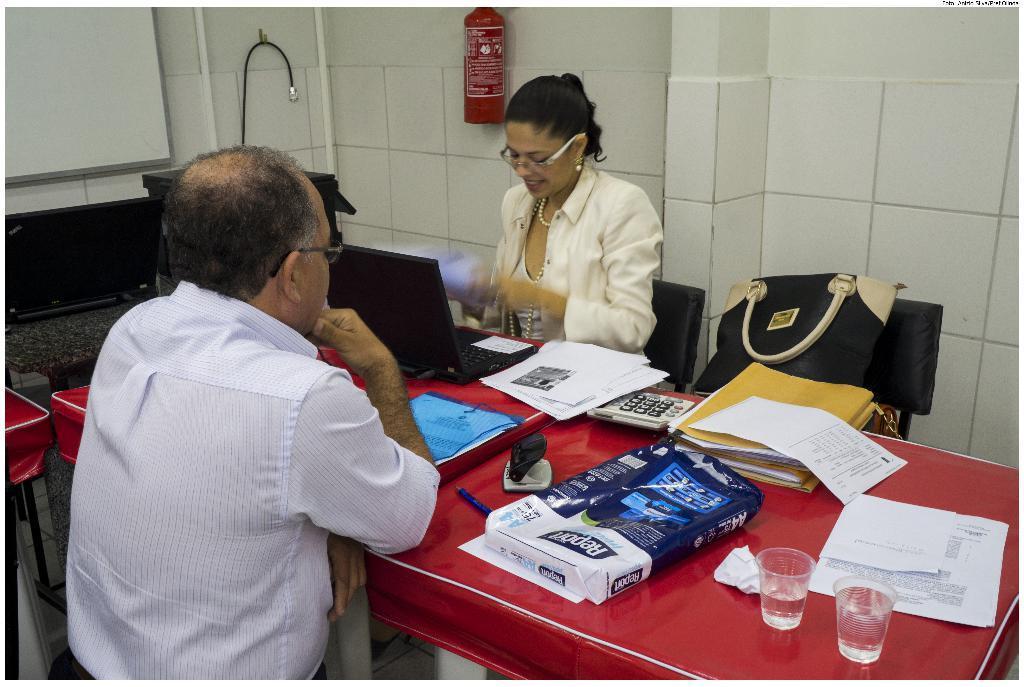Can you describe this image briefly? In this picture we can see man and woman sitting on chairs and in front of them there is table and on table we can see glasses, papers, files, calculator, pen, laptop and aside to this woman there is bag and in background we can see wall, fire extinguisher. 